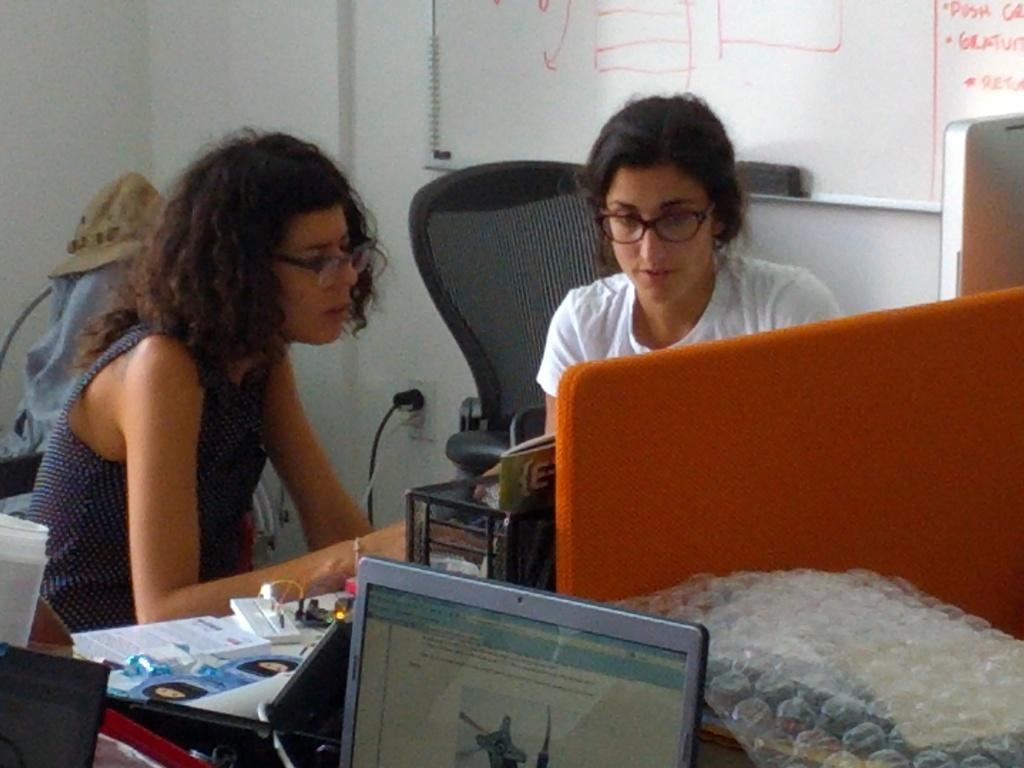Can you describe this image briefly? Here we can see two women and they have spectacles. This is table. On the table there are laptops, and papers. There is a chair and a cap. In the background we can see a wall and a board. 